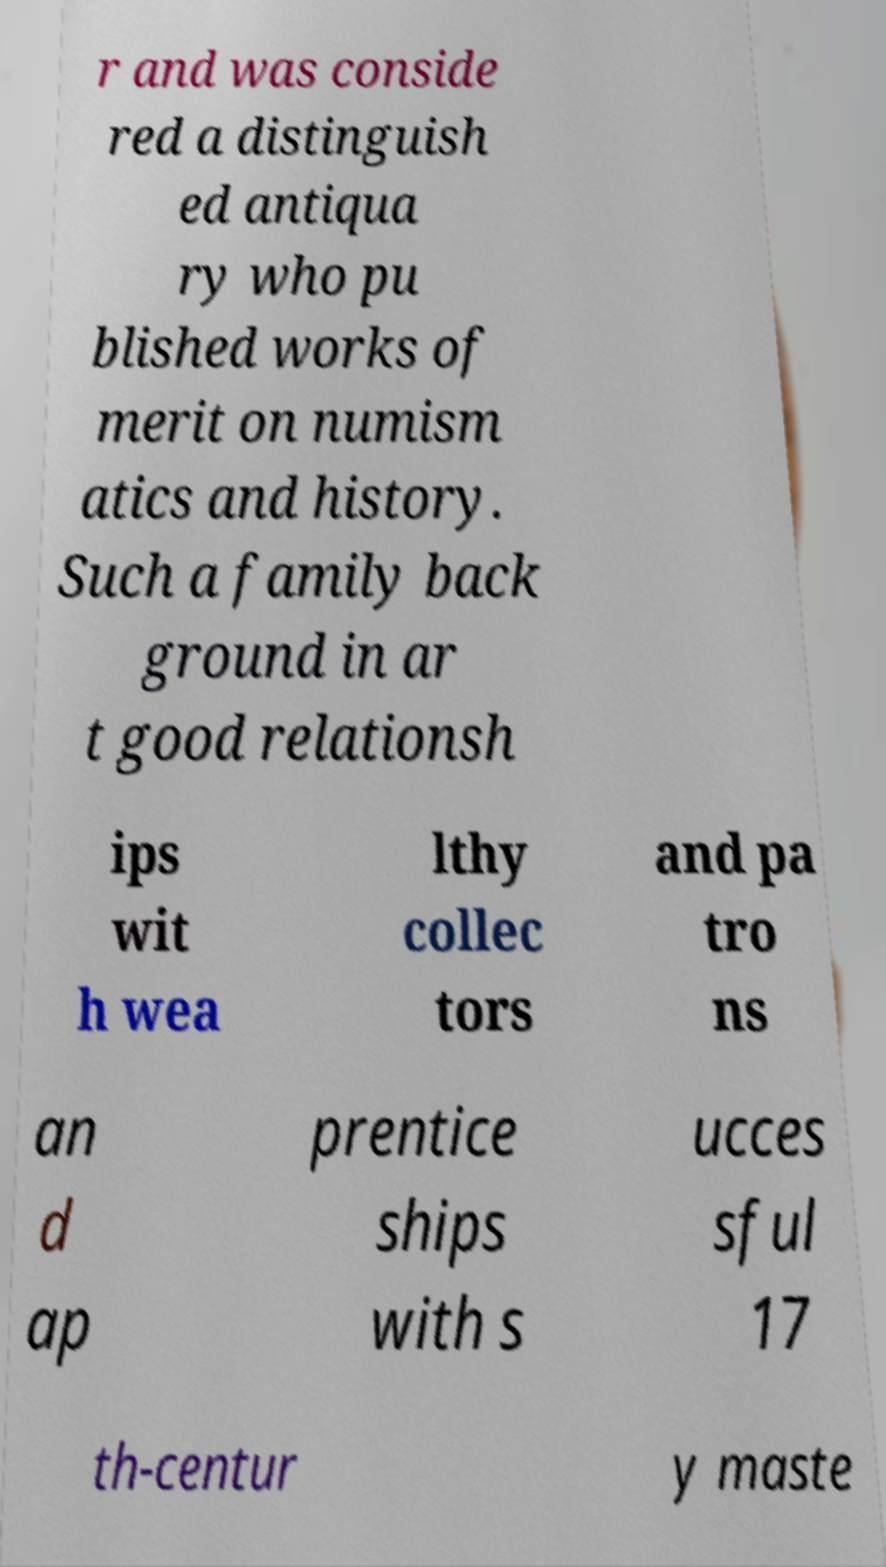Can you read and provide the text displayed in the image?This photo seems to have some interesting text. Can you extract and type it out for me? r and was conside red a distinguish ed antiqua ry who pu blished works of merit on numism atics and history. Such a family back ground in ar t good relationsh ips wit h wea lthy collec tors and pa tro ns an d ap prentice ships with s ucces sful 17 th-centur y maste 